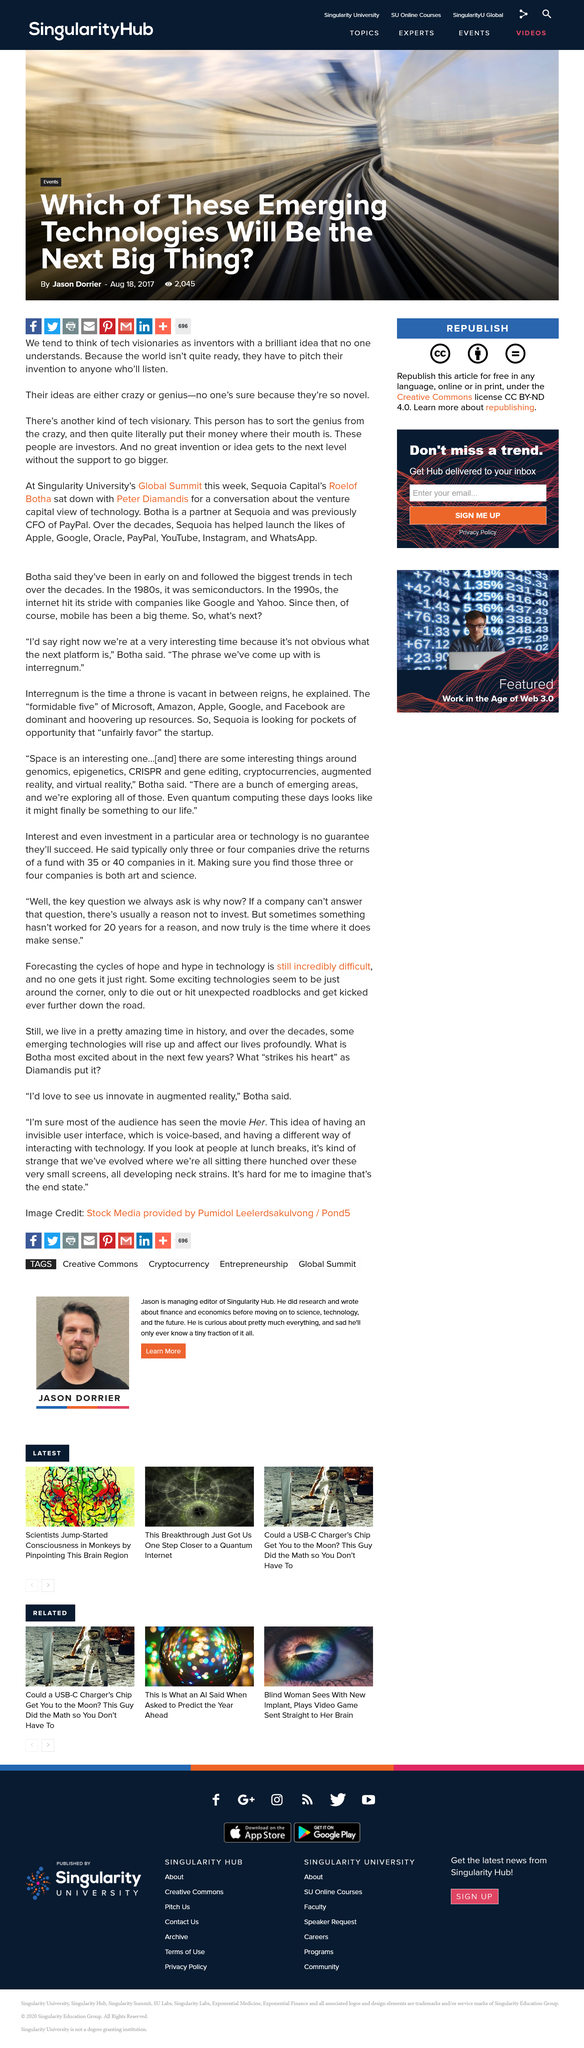Draw attention to some important aspects in this diagram. I declare that the support for great inventions and ideas is crucial in helping them reach the next level of development. Jason Dorrier, the author of the article titled "Which of These Emerging Technologies Will Be the Next Big Thing?", wrote the article. Tech visionaries are often perceived as inventors with innovative ideas that are misunderstood by the general public. 